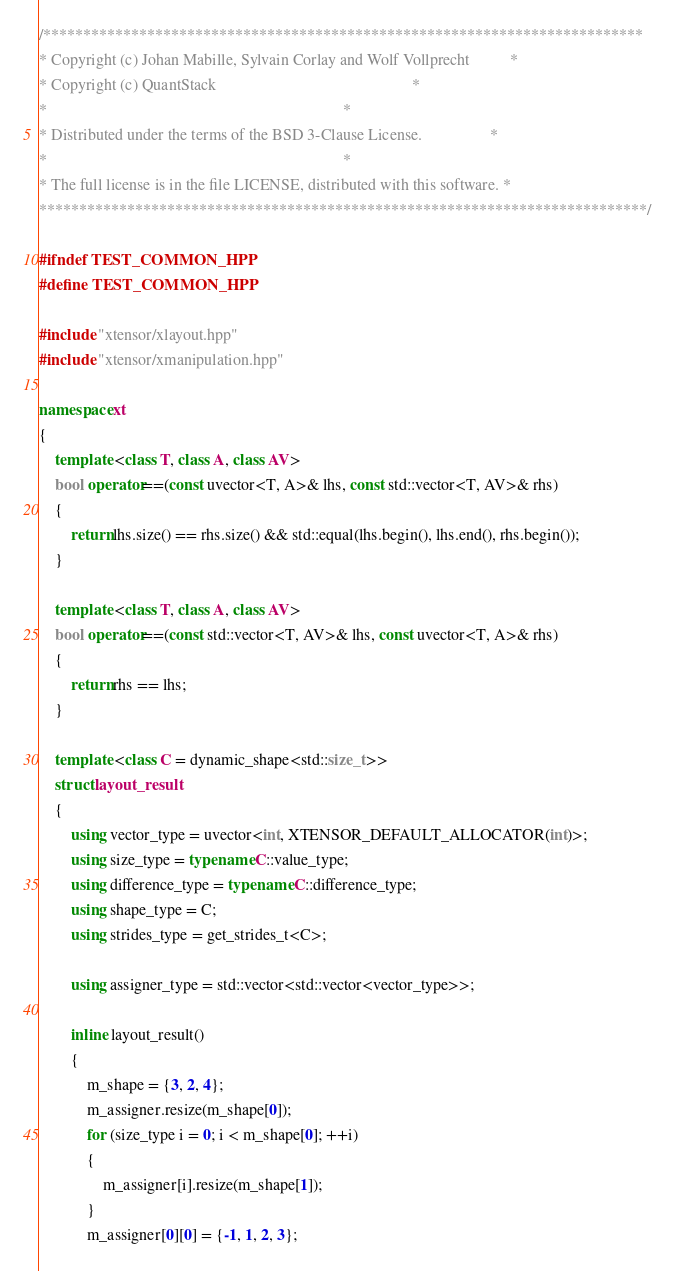Convert code to text. <code><loc_0><loc_0><loc_500><loc_500><_C++_>/***************************************************************************
* Copyright (c) Johan Mabille, Sylvain Corlay and Wolf Vollprecht          *
* Copyright (c) QuantStack                                                 *
*                                                                          *
* Distributed under the terms of the BSD 3-Clause License.                 *
*                                                                          *
* The full license is in the file LICENSE, distributed with this software. *
****************************************************************************/

#ifndef TEST_COMMON_HPP
#define TEST_COMMON_HPP

#include "xtensor/xlayout.hpp"
#include "xtensor/xmanipulation.hpp"

namespace xt
{
    template <class T, class A, class AV>
    bool operator==(const uvector<T, A>& lhs, const std::vector<T, AV>& rhs)
    {
        return lhs.size() == rhs.size() && std::equal(lhs.begin(), lhs.end(), rhs.begin());
    }

    template <class T, class A, class AV>
    bool operator==(const std::vector<T, AV>& lhs, const uvector<T, A>& rhs)
    {
        return rhs == lhs;
    }

    template <class C = dynamic_shape<std::size_t>>
    struct layout_result
    {
        using vector_type = uvector<int, XTENSOR_DEFAULT_ALLOCATOR(int)>;
        using size_type = typename C::value_type;
        using difference_type = typename C::difference_type;
        using shape_type = C;
        using strides_type = get_strides_t<C>;

        using assigner_type = std::vector<std::vector<vector_type>>;

        inline layout_result()
        {
            m_shape = {3, 2, 4};
            m_assigner.resize(m_shape[0]);
            for (size_type i = 0; i < m_shape[0]; ++i)
            {
                m_assigner[i].resize(m_shape[1]);
            }
            m_assigner[0][0] = {-1, 1, 2, 3};</code> 